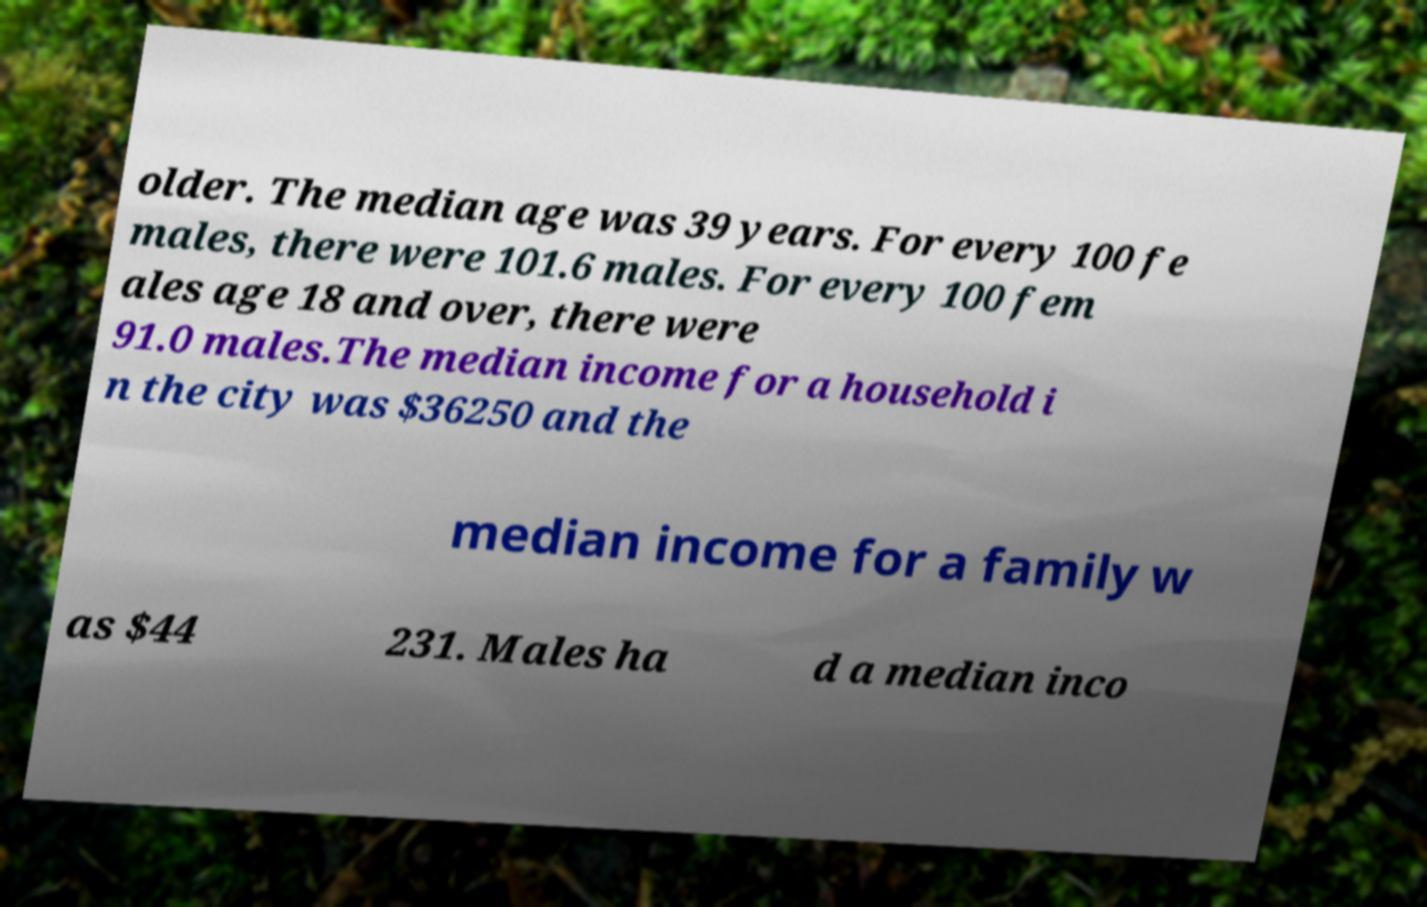Can you accurately transcribe the text from the provided image for me? older. The median age was 39 years. For every 100 fe males, there were 101.6 males. For every 100 fem ales age 18 and over, there were 91.0 males.The median income for a household i n the city was $36250 and the median income for a family w as $44 231. Males ha d a median inco 